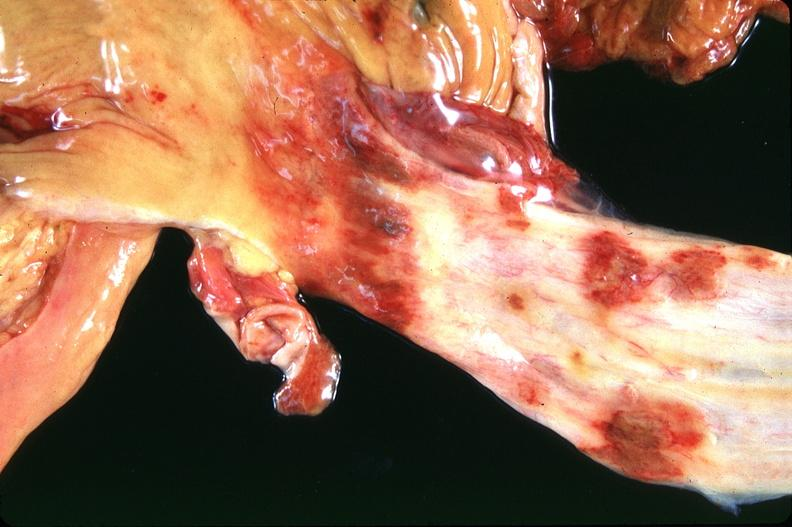does this image show stomach and esophagus, ulcers?
Answer the question using a single word or phrase. Yes 